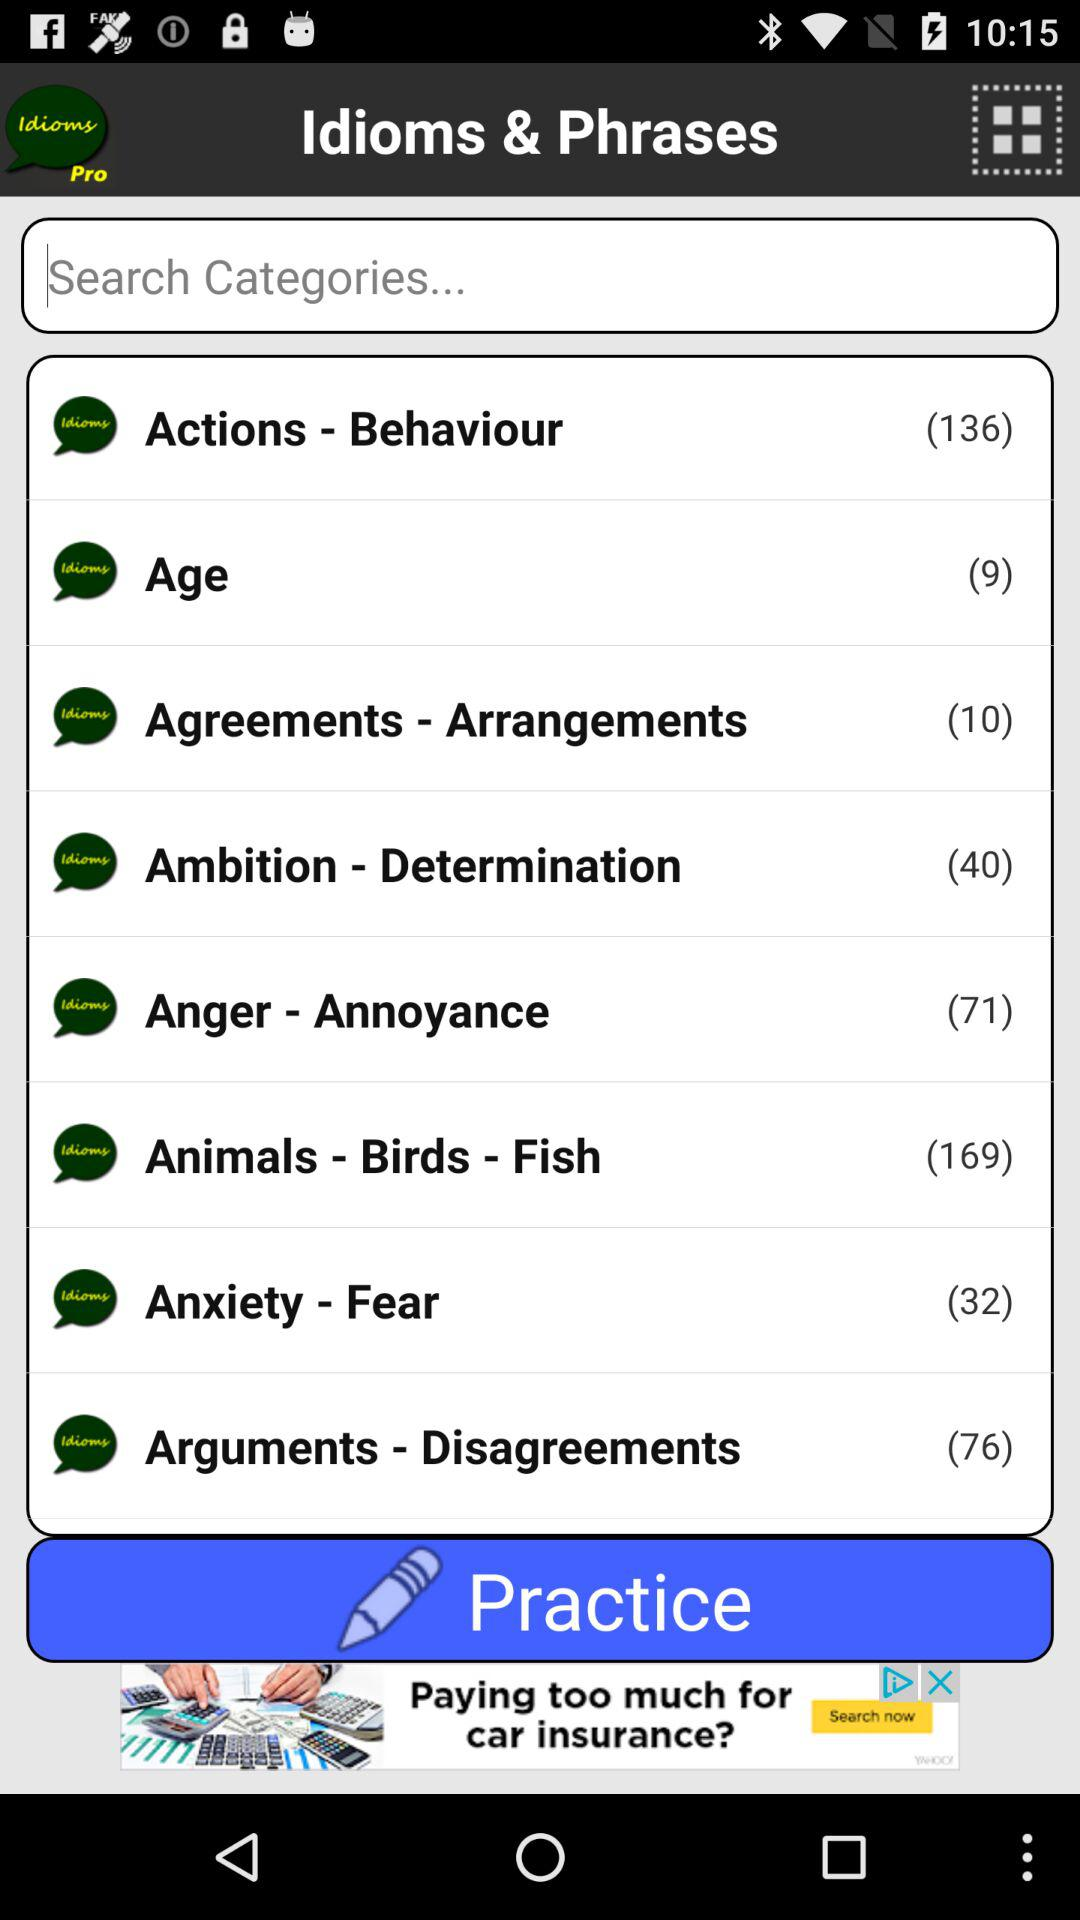How many idioms and phrases are there in "Actions - Behaviour" category? There are 136 idioms and phrases in "Actions - Behaviour" category. 